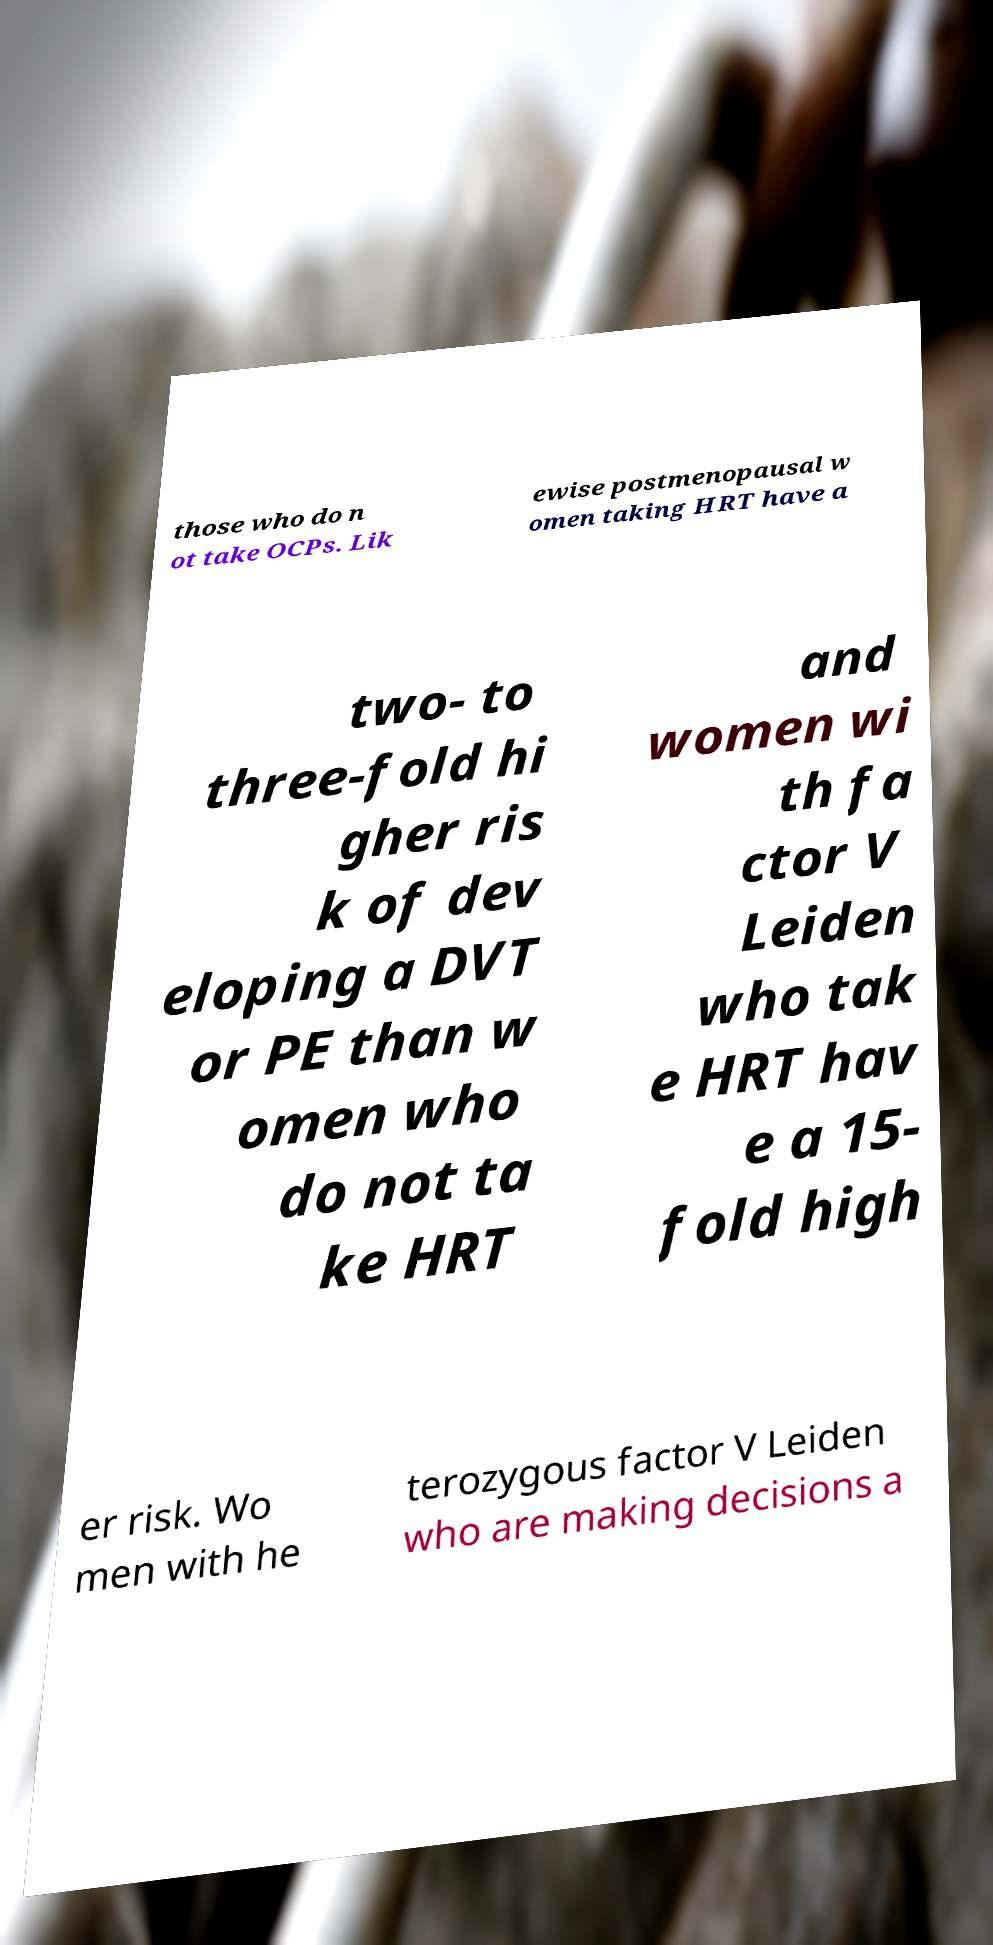Could you assist in decoding the text presented in this image and type it out clearly? those who do n ot take OCPs. Lik ewise postmenopausal w omen taking HRT have a two- to three-fold hi gher ris k of dev eloping a DVT or PE than w omen who do not ta ke HRT and women wi th fa ctor V Leiden who tak e HRT hav e a 15- fold high er risk. Wo men with he terozygous factor V Leiden who are making decisions a 